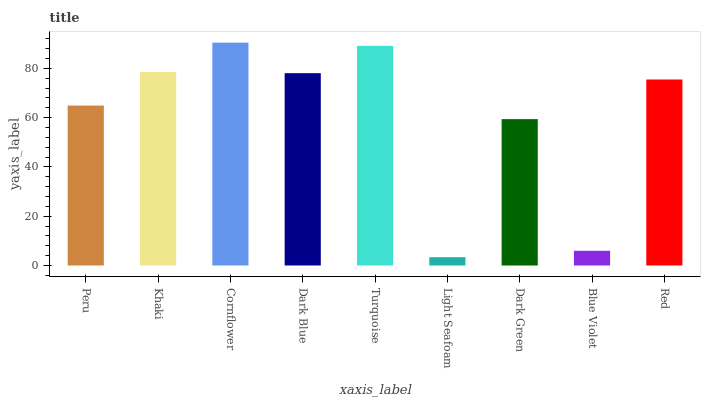Is Light Seafoam the minimum?
Answer yes or no. Yes. Is Cornflower the maximum?
Answer yes or no. Yes. Is Khaki the minimum?
Answer yes or no. No. Is Khaki the maximum?
Answer yes or no. No. Is Khaki greater than Peru?
Answer yes or no. Yes. Is Peru less than Khaki?
Answer yes or no. Yes. Is Peru greater than Khaki?
Answer yes or no. No. Is Khaki less than Peru?
Answer yes or no. No. Is Red the high median?
Answer yes or no. Yes. Is Red the low median?
Answer yes or no. Yes. Is Cornflower the high median?
Answer yes or no. No. Is Turquoise the low median?
Answer yes or no. No. 